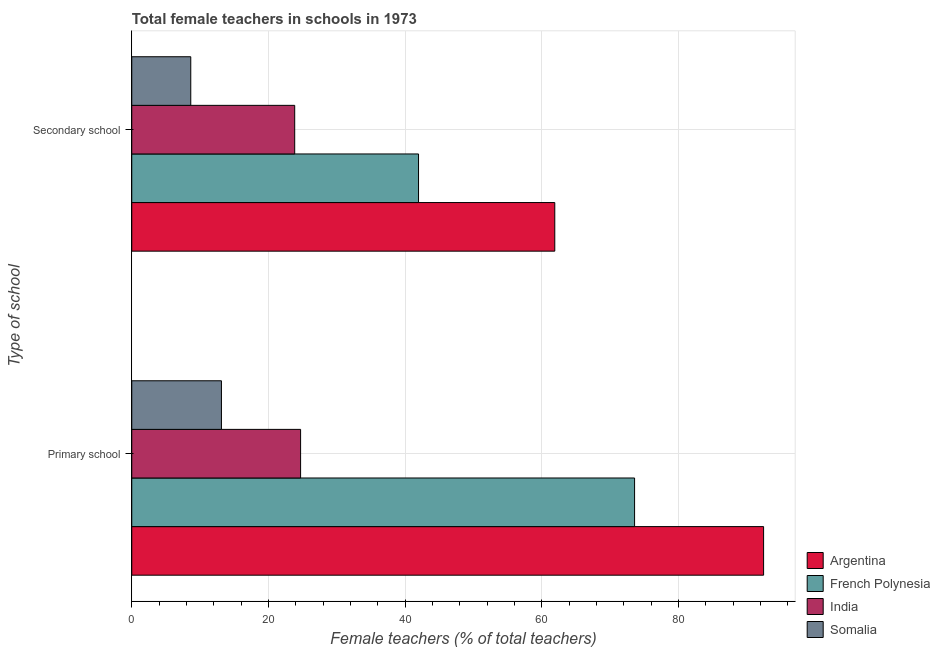How many groups of bars are there?
Ensure brevity in your answer.  2. Are the number of bars per tick equal to the number of legend labels?
Make the answer very short. Yes. What is the label of the 1st group of bars from the top?
Your answer should be very brief. Secondary school. What is the percentage of female teachers in primary schools in India?
Your answer should be compact. 24.71. Across all countries, what is the maximum percentage of female teachers in secondary schools?
Ensure brevity in your answer.  61.91. Across all countries, what is the minimum percentage of female teachers in secondary schools?
Keep it short and to the point. 8.63. In which country was the percentage of female teachers in primary schools minimum?
Make the answer very short. Somalia. What is the total percentage of female teachers in primary schools in the graph?
Offer a very short reply. 203.9. What is the difference between the percentage of female teachers in secondary schools in India and that in French Polynesia?
Provide a succinct answer. -18.12. What is the difference between the percentage of female teachers in secondary schools in Somalia and the percentage of female teachers in primary schools in Argentina?
Keep it short and to the point. -83.84. What is the average percentage of female teachers in secondary schools per country?
Offer a terse response. 34.09. What is the difference between the percentage of female teachers in primary schools and percentage of female teachers in secondary schools in India?
Keep it short and to the point. 0.86. In how many countries, is the percentage of female teachers in primary schools greater than 8 %?
Give a very brief answer. 4. What is the ratio of the percentage of female teachers in primary schools in Argentina to that in French Polynesia?
Give a very brief answer. 1.26. What does the 4th bar from the top in Primary school represents?
Make the answer very short. Argentina. What does the 1st bar from the bottom in Primary school represents?
Offer a very short reply. Argentina. How many bars are there?
Provide a short and direct response. 8. How many countries are there in the graph?
Offer a terse response. 4. What is the difference between two consecutive major ticks on the X-axis?
Offer a very short reply. 20. Where does the legend appear in the graph?
Offer a very short reply. Bottom right. How are the legend labels stacked?
Your answer should be very brief. Vertical. What is the title of the graph?
Your answer should be very brief. Total female teachers in schools in 1973. What is the label or title of the X-axis?
Provide a succinct answer. Female teachers (% of total teachers). What is the label or title of the Y-axis?
Your answer should be compact. Type of school. What is the Female teachers (% of total teachers) in Argentina in Primary school?
Your answer should be very brief. 92.47. What is the Female teachers (% of total teachers) in French Polynesia in Primary school?
Your answer should be very brief. 73.59. What is the Female teachers (% of total teachers) of India in Primary school?
Provide a succinct answer. 24.71. What is the Female teachers (% of total teachers) of Somalia in Primary school?
Your answer should be compact. 13.13. What is the Female teachers (% of total teachers) in Argentina in Secondary school?
Your answer should be compact. 61.91. What is the Female teachers (% of total teachers) of French Polynesia in Secondary school?
Make the answer very short. 41.97. What is the Female teachers (% of total teachers) in India in Secondary school?
Your response must be concise. 23.85. What is the Female teachers (% of total teachers) in Somalia in Secondary school?
Your answer should be compact. 8.63. Across all Type of school, what is the maximum Female teachers (% of total teachers) of Argentina?
Provide a succinct answer. 92.47. Across all Type of school, what is the maximum Female teachers (% of total teachers) in French Polynesia?
Keep it short and to the point. 73.59. Across all Type of school, what is the maximum Female teachers (% of total teachers) of India?
Provide a short and direct response. 24.71. Across all Type of school, what is the maximum Female teachers (% of total teachers) in Somalia?
Ensure brevity in your answer.  13.13. Across all Type of school, what is the minimum Female teachers (% of total teachers) of Argentina?
Provide a short and direct response. 61.91. Across all Type of school, what is the minimum Female teachers (% of total teachers) of French Polynesia?
Your response must be concise. 41.97. Across all Type of school, what is the minimum Female teachers (% of total teachers) of India?
Ensure brevity in your answer.  23.85. Across all Type of school, what is the minimum Female teachers (% of total teachers) of Somalia?
Give a very brief answer. 8.63. What is the total Female teachers (% of total teachers) in Argentina in the graph?
Make the answer very short. 154.38. What is the total Female teachers (% of total teachers) in French Polynesia in the graph?
Your answer should be very brief. 115.56. What is the total Female teachers (% of total teachers) in India in the graph?
Your answer should be very brief. 48.56. What is the total Female teachers (% of total teachers) in Somalia in the graph?
Offer a very short reply. 21.76. What is the difference between the Female teachers (% of total teachers) of Argentina in Primary school and that in Secondary school?
Provide a short and direct response. 30.56. What is the difference between the Female teachers (% of total teachers) of French Polynesia in Primary school and that in Secondary school?
Offer a very short reply. 31.62. What is the difference between the Female teachers (% of total teachers) of India in Primary school and that in Secondary school?
Offer a very short reply. 0.86. What is the difference between the Female teachers (% of total teachers) in Somalia in Primary school and that in Secondary school?
Make the answer very short. 4.49. What is the difference between the Female teachers (% of total teachers) of Argentina in Primary school and the Female teachers (% of total teachers) of French Polynesia in Secondary school?
Offer a very short reply. 50.5. What is the difference between the Female teachers (% of total teachers) in Argentina in Primary school and the Female teachers (% of total teachers) in India in Secondary school?
Provide a short and direct response. 68.62. What is the difference between the Female teachers (% of total teachers) in Argentina in Primary school and the Female teachers (% of total teachers) in Somalia in Secondary school?
Your answer should be very brief. 83.84. What is the difference between the Female teachers (% of total teachers) of French Polynesia in Primary school and the Female teachers (% of total teachers) of India in Secondary school?
Your response must be concise. 49.74. What is the difference between the Female teachers (% of total teachers) in French Polynesia in Primary school and the Female teachers (% of total teachers) in Somalia in Secondary school?
Your answer should be very brief. 64.96. What is the difference between the Female teachers (% of total teachers) of India in Primary school and the Female teachers (% of total teachers) of Somalia in Secondary school?
Give a very brief answer. 16.07. What is the average Female teachers (% of total teachers) in Argentina per Type of school?
Give a very brief answer. 77.19. What is the average Female teachers (% of total teachers) in French Polynesia per Type of school?
Keep it short and to the point. 57.78. What is the average Female teachers (% of total teachers) in India per Type of school?
Make the answer very short. 24.28. What is the average Female teachers (% of total teachers) of Somalia per Type of school?
Keep it short and to the point. 10.88. What is the difference between the Female teachers (% of total teachers) of Argentina and Female teachers (% of total teachers) of French Polynesia in Primary school?
Make the answer very short. 18.88. What is the difference between the Female teachers (% of total teachers) in Argentina and Female teachers (% of total teachers) in India in Primary school?
Make the answer very short. 67.76. What is the difference between the Female teachers (% of total teachers) of Argentina and Female teachers (% of total teachers) of Somalia in Primary school?
Provide a short and direct response. 79.35. What is the difference between the Female teachers (% of total teachers) of French Polynesia and Female teachers (% of total teachers) of India in Primary school?
Offer a very short reply. 48.88. What is the difference between the Female teachers (% of total teachers) in French Polynesia and Female teachers (% of total teachers) in Somalia in Primary school?
Give a very brief answer. 60.46. What is the difference between the Female teachers (% of total teachers) of India and Female teachers (% of total teachers) of Somalia in Primary school?
Give a very brief answer. 11.58. What is the difference between the Female teachers (% of total teachers) of Argentina and Female teachers (% of total teachers) of French Polynesia in Secondary school?
Provide a succinct answer. 19.94. What is the difference between the Female teachers (% of total teachers) of Argentina and Female teachers (% of total teachers) of India in Secondary school?
Your answer should be very brief. 38.06. What is the difference between the Female teachers (% of total teachers) of Argentina and Female teachers (% of total teachers) of Somalia in Secondary school?
Offer a very short reply. 53.28. What is the difference between the Female teachers (% of total teachers) in French Polynesia and Female teachers (% of total teachers) in India in Secondary school?
Provide a short and direct response. 18.12. What is the difference between the Female teachers (% of total teachers) of French Polynesia and Female teachers (% of total teachers) of Somalia in Secondary school?
Provide a short and direct response. 33.34. What is the difference between the Female teachers (% of total teachers) of India and Female teachers (% of total teachers) of Somalia in Secondary school?
Your answer should be very brief. 15.21. What is the ratio of the Female teachers (% of total teachers) of Argentina in Primary school to that in Secondary school?
Keep it short and to the point. 1.49. What is the ratio of the Female teachers (% of total teachers) of French Polynesia in Primary school to that in Secondary school?
Keep it short and to the point. 1.75. What is the ratio of the Female teachers (% of total teachers) in India in Primary school to that in Secondary school?
Give a very brief answer. 1.04. What is the ratio of the Female teachers (% of total teachers) in Somalia in Primary school to that in Secondary school?
Offer a terse response. 1.52. What is the difference between the highest and the second highest Female teachers (% of total teachers) in Argentina?
Your response must be concise. 30.56. What is the difference between the highest and the second highest Female teachers (% of total teachers) of French Polynesia?
Your answer should be very brief. 31.62. What is the difference between the highest and the second highest Female teachers (% of total teachers) of India?
Ensure brevity in your answer.  0.86. What is the difference between the highest and the second highest Female teachers (% of total teachers) of Somalia?
Offer a terse response. 4.49. What is the difference between the highest and the lowest Female teachers (% of total teachers) in Argentina?
Your answer should be compact. 30.56. What is the difference between the highest and the lowest Female teachers (% of total teachers) of French Polynesia?
Provide a short and direct response. 31.62. What is the difference between the highest and the lowest Female teachers (% of total teachers) in India?
Provide a short and direct response. 0.86. What is the difference between the highest and the lowest Female teachers (% of total teachers) in Somalia?
Provide a succinct answer. 4.49. 